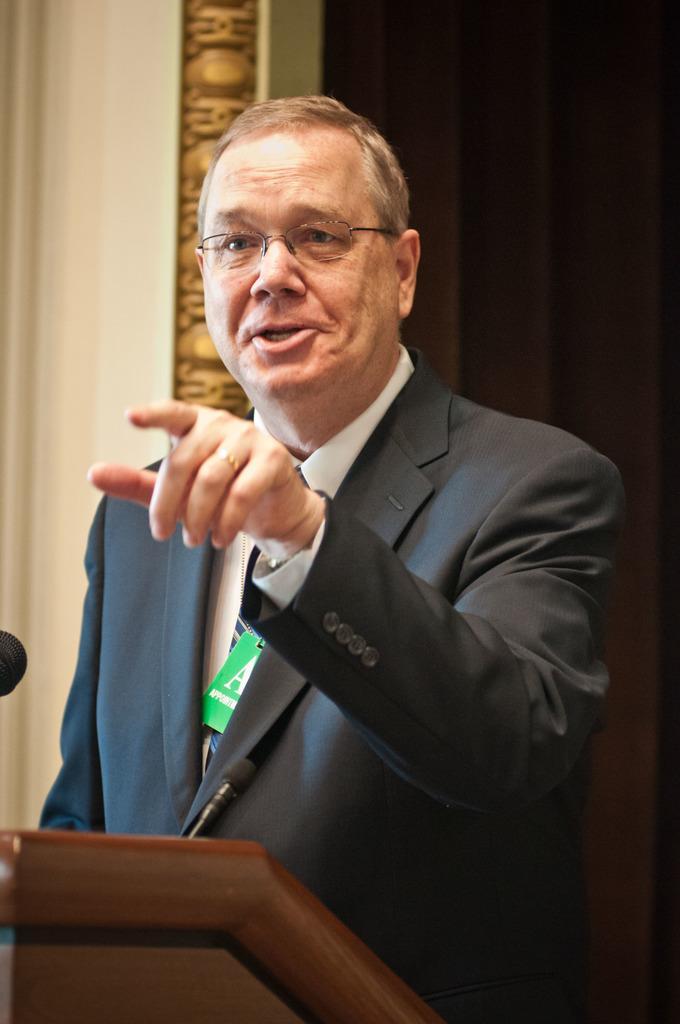How would you summarize this image in a sentence or two? In this picture we can see the old man wearing black suit, standing in the front and showing his finger and shouting. Behind there is a wall and curtain. 